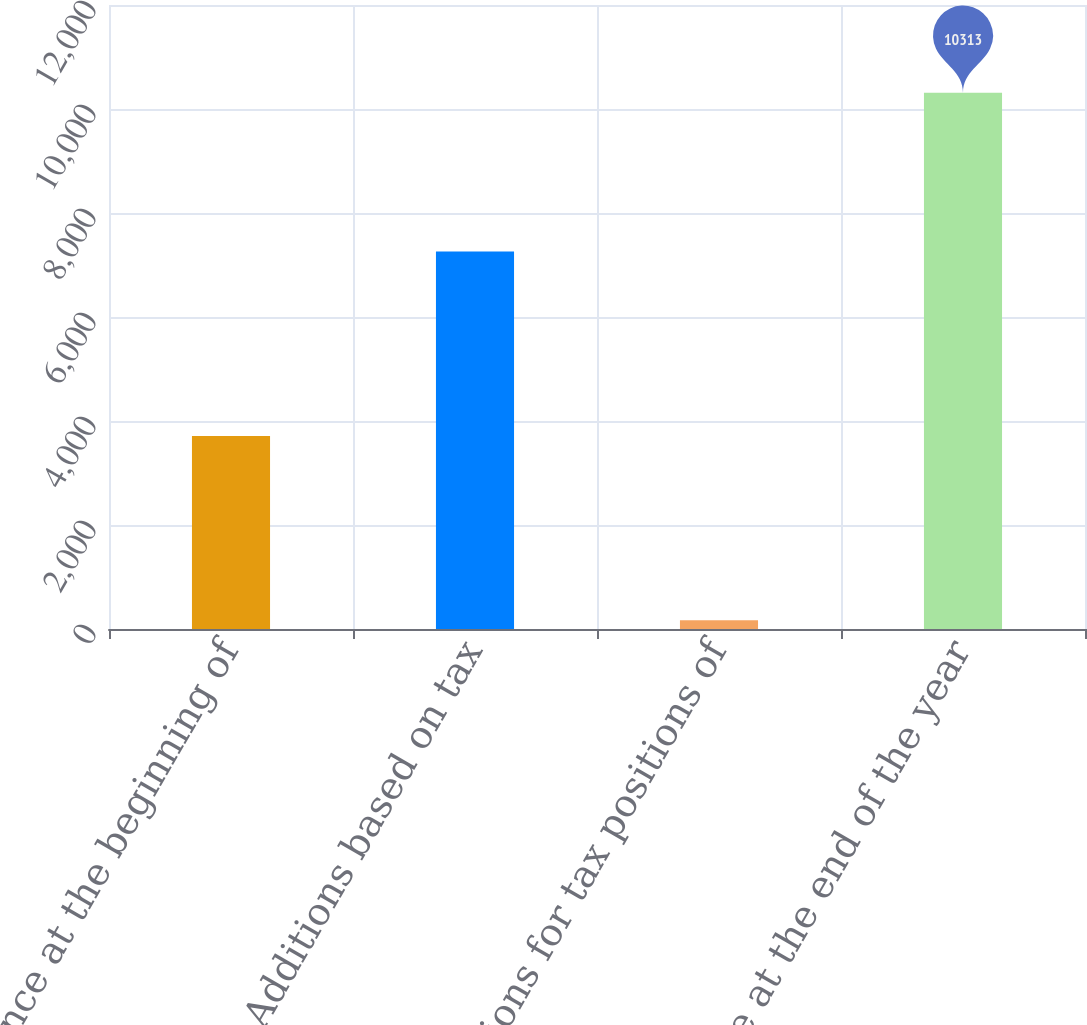Convert chart. <chart><loc_0><loc_0><loc_500><loc_500><bar_chart><fcel>Balance at the beginning of<fcel>Additions based on tax<fcel>Additions for tax positions of<fcel>Balance at the end of the year<nl><fcel>3713<fcel>7258<fcel>167<fcel>10313<nl></chart> 